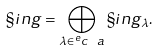Convert formula to latex. <formula><loc_0><loc_0><loc_500><loc_500>\S i n g = \bigoplus _ { \lambda \in ^ { e } c \ a } \S i n g _ { \lambda } .</formula> 